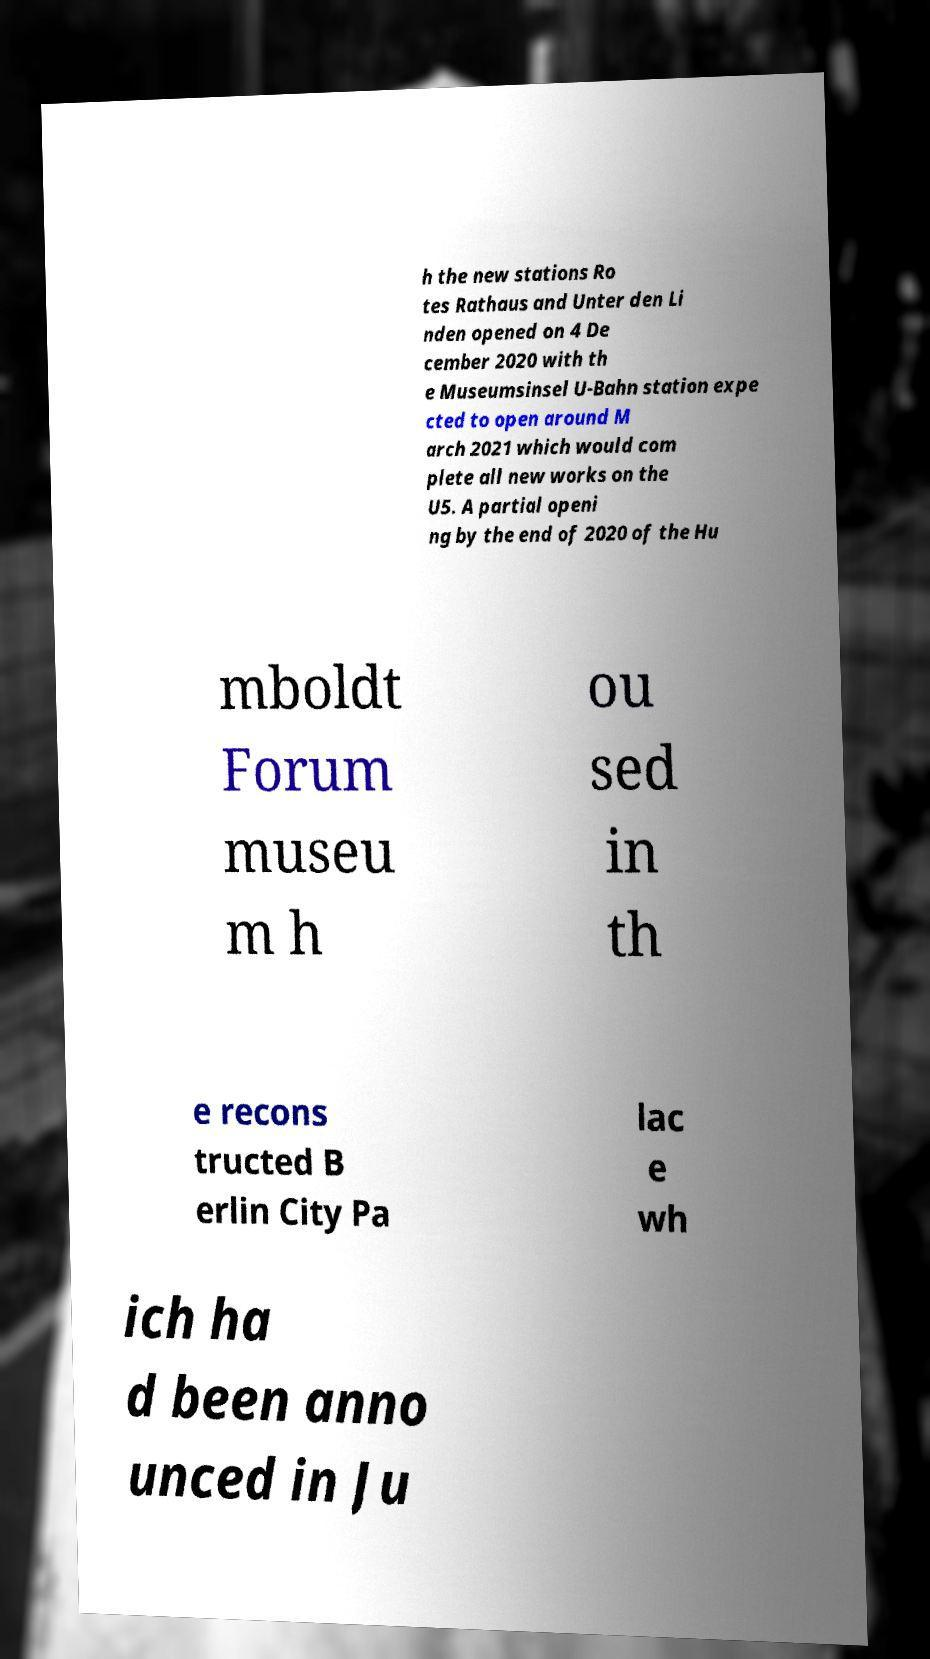Can you accurately transcribe the text from the provided image for me? h the new stations Ro tes Rathaus and Unter den Li nden opened on 4 De cember 2020 with th e Museumsinsel U-Bahn station expe cted to open around M arch 2021 which would com plete all new works on the U5. A partial openi ng by the end of 2020 of the Hu mboldt Forum museu m h ou sed in th e recons tructed B erlin City Pa lac e wh ich ha d been anno unced in Ju 